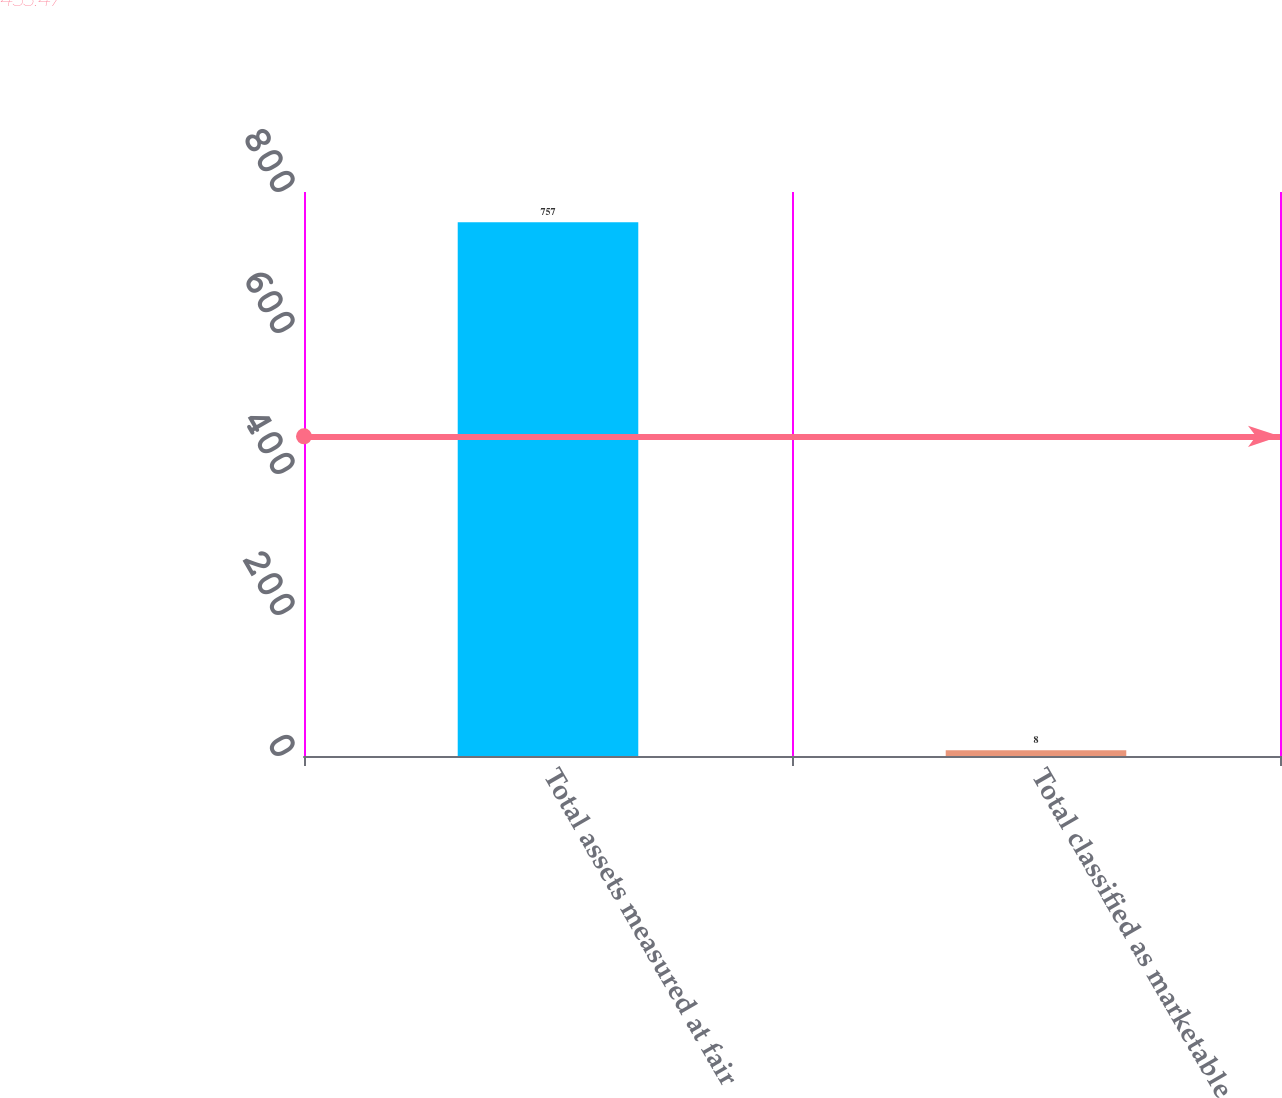<chart> <loc_0><loc_0><loc_500><loc_500><bar_chart><fcel>Total assets measured at fair<fcel>Total classified as marketable<nl><fcel>757<fcel>8<nl></chart> 